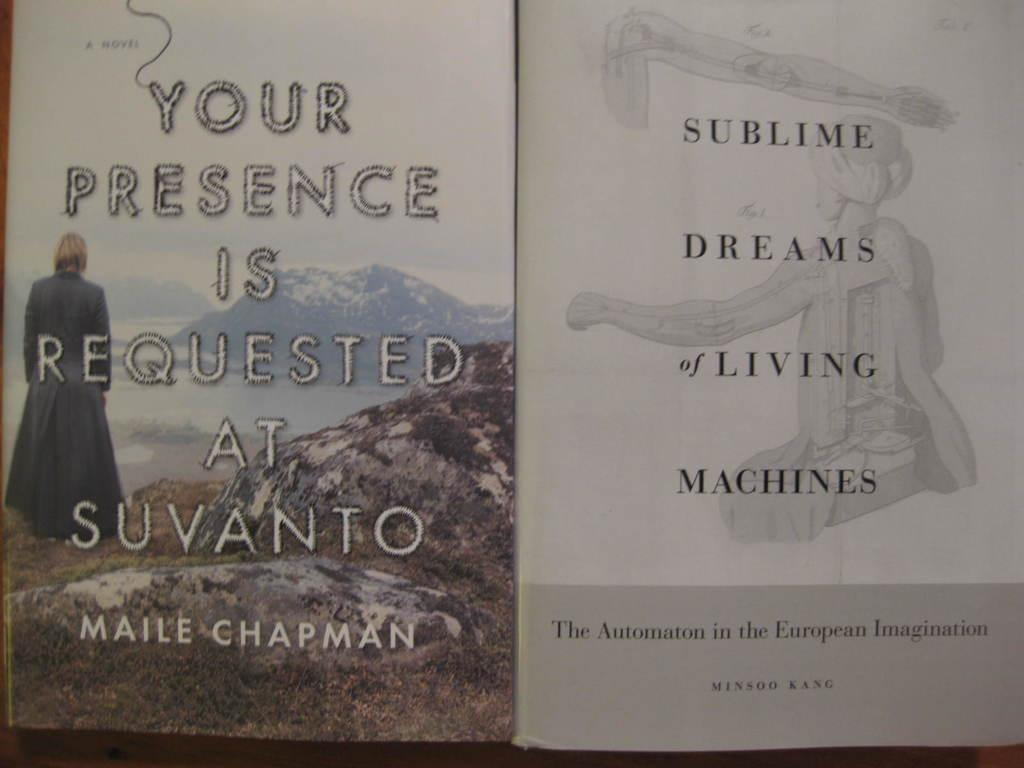<image>
Describe the image concisely. A book called Sublime Dreams and Living Machines shows a mountain scene on the cover 